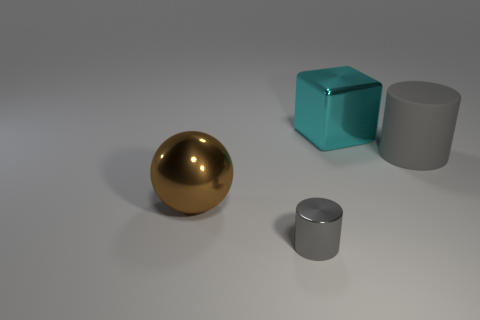Subtract all balls. How many objects are left? 3 Add 4 gray blocks. How many objects exist? 8 Subtract all red cylinders. Subtract all red blocks. How many cylinders are left? 2 Subtract all large purple objects. Subtract all metal cylinders. How many objects are left? 3 Add 1 matte cylinders. How many matte cylinders are left? 2 Add 2 brown rubber things. How many brown rubber things exist? 2 Subtract 0 gray blocks. How many objects are left? 4 